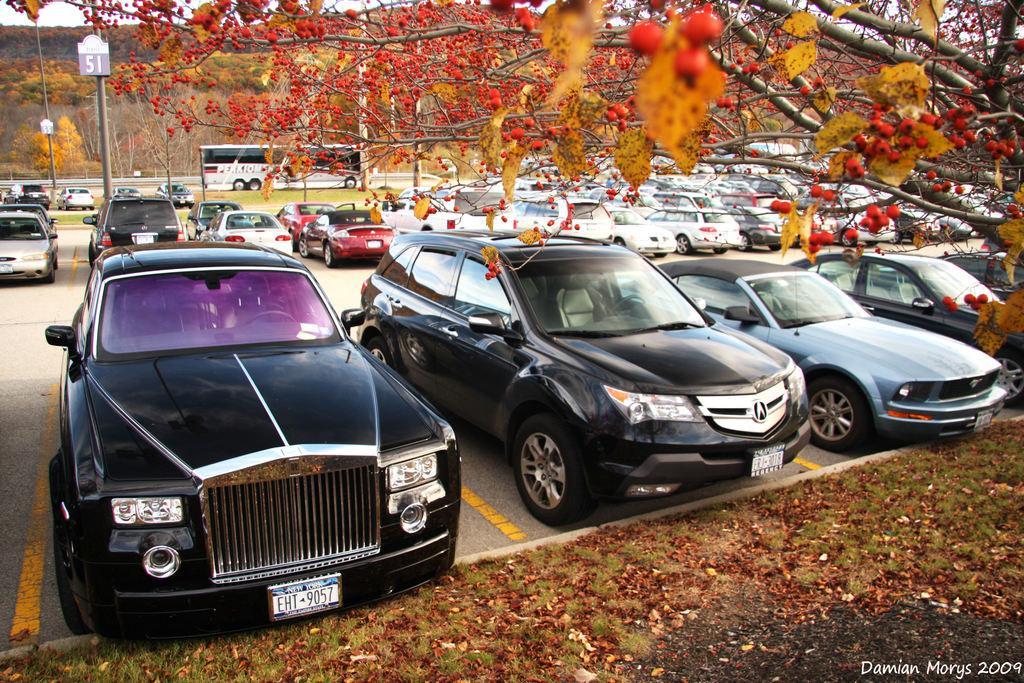How would you summarize this image in a sentence or two? In this image in the front there are dry leaves on the ground. In the center there are vehicles and on the top there are trees. In the background there are poles and there are trees and there's grass on the ground. 